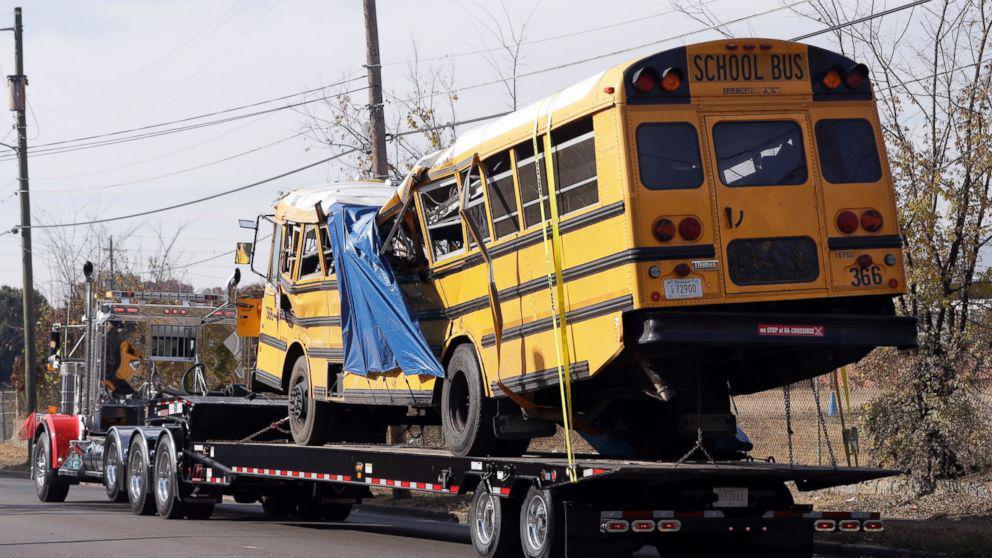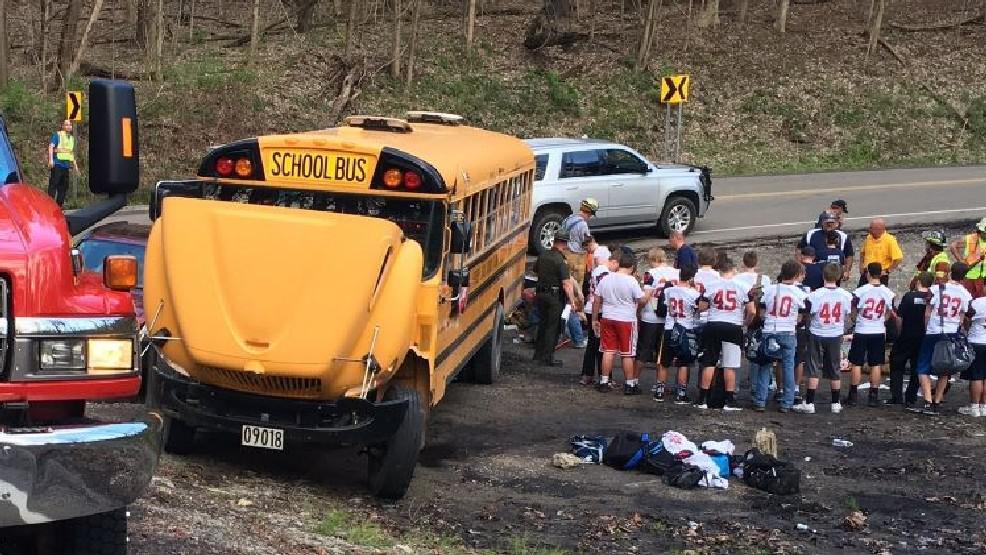The first image is the image on the left, the second image is the image on the right. For the images shown, is this caption "A blue tarp covers the side of the bus in one of the images." true? Answer yes or no. Yes. The first image is the image on the left, the second image is the image on the right. Examine the images to the left and right. Is the description "there is a bus on the back of a flat bed tow truck" accurate? Answer yes or no. Yes. 